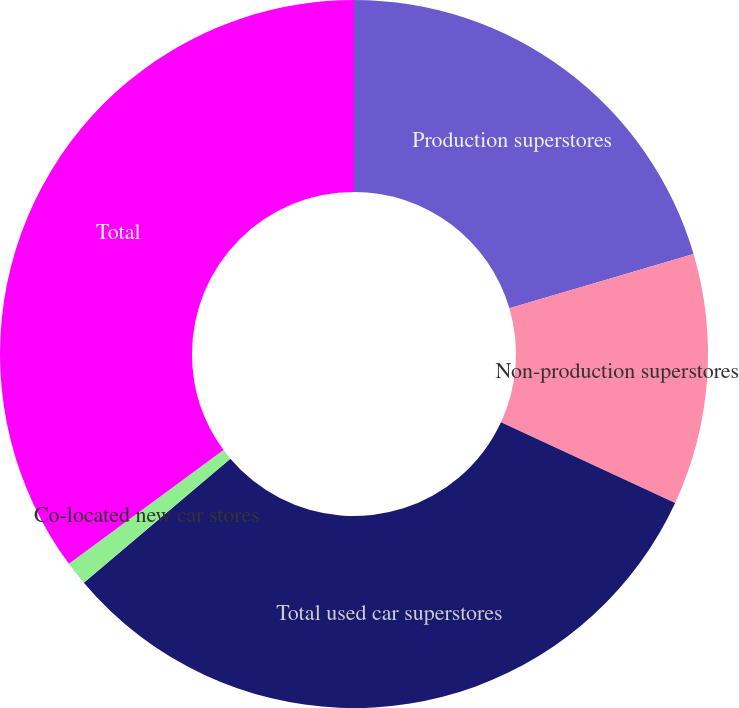Convert chart. <chart><loc_0><loc_0><loc_500><loc_500><pie_chart><fcel>Production superstores<fcel>Non-production superstores<fcel>Total used car superstores<fcel>Co-located new car stores<fcel>Total<nl><fcel>20.44%<fcel>11.47%<fcel>31.91%<fcel>1.08%<fcel>35.1%<nl></chart> 